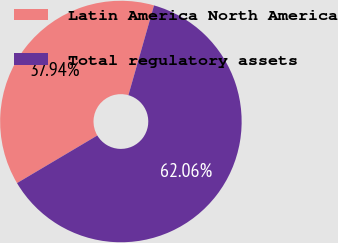Convert chart. <chart><loc_0><loc_0><loc_500><loc_500><pie_chart><fcel>Latin America North America<fcel>Total regulatory assets<nl><fcel>37.94%<fcel>62.06%<nl></chart> 